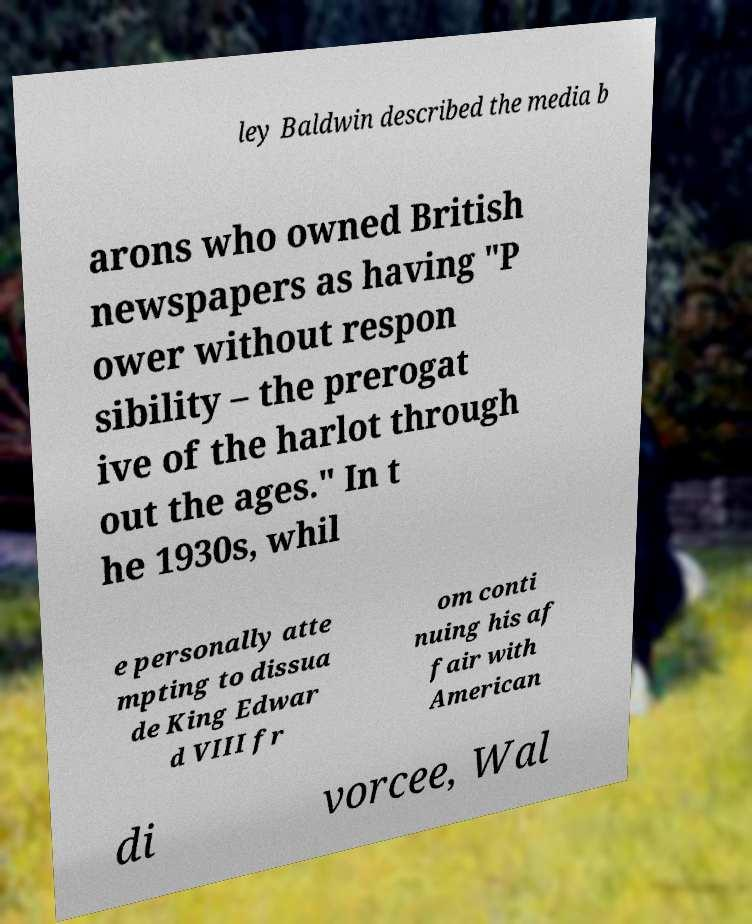Can you accurately transcribe the text from the provided image for me? ley Baldwin described the media b arons who owned British newspapers as having "P ower without respon sibility – the prerogat ive of the harlot through out the ages." In t he 1930s, whil e personally atte mpting to dissua de King Edwar d VIII fr om conti nuing his af fair with American di vorcee, Wal 